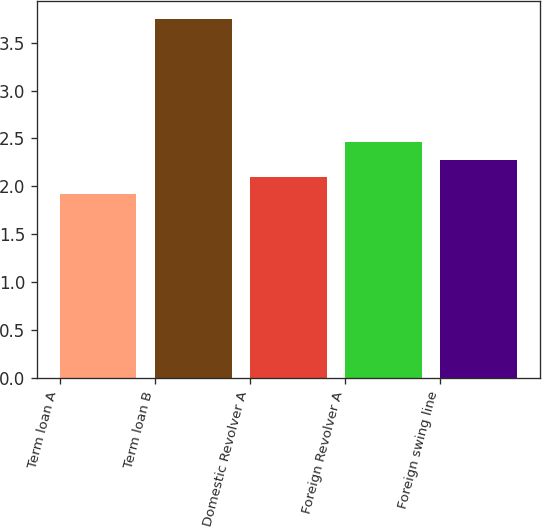Convert chart. <chart><loc_0><loc_0><loc_500><loc_500><bar_chart><fcel>Term loan A<fcel>Term loan B<fcel>Domestic Revolver A<fcel>Foreign Revolver A<fcel>Foreign swing line<nl><fcel>1.92<fcel>3.75<fcel>2.1<fcel>2.46<fcel>2.28<nl></chart> 